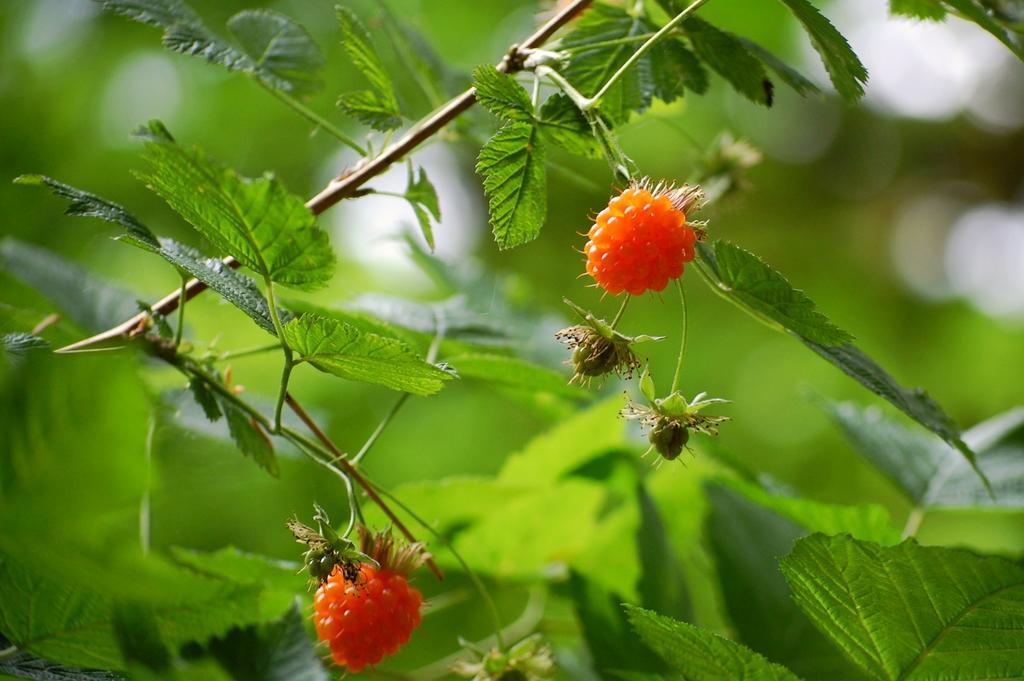Please provide a concise description of this image. In this image I can see an insect on the fruit and I can see few fruits in orange color. In the background I can see few plants in green color. 